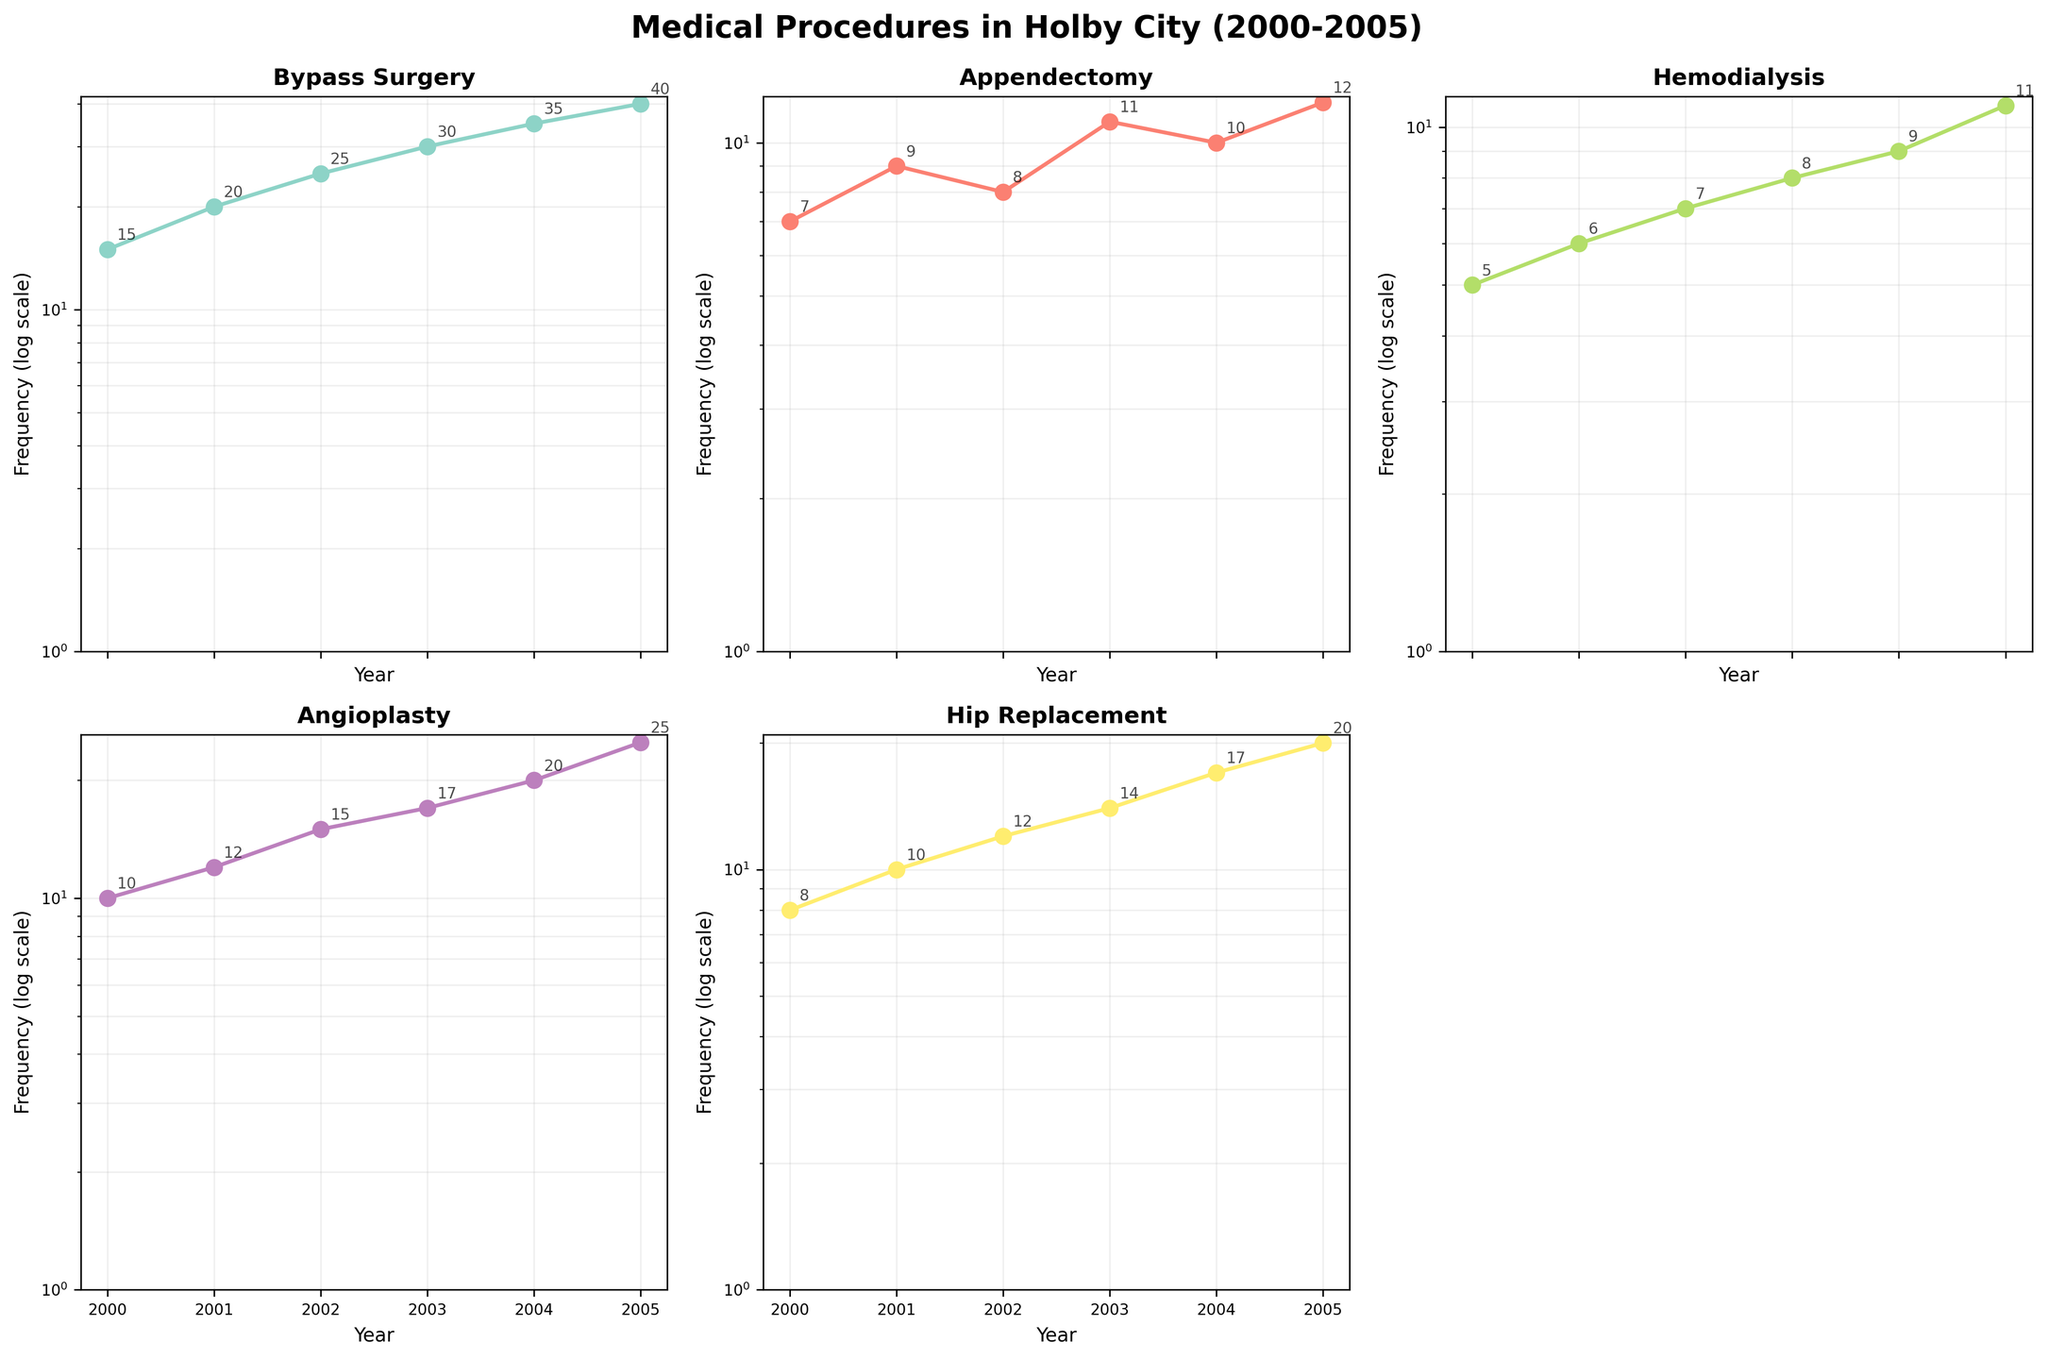When does the subplot indicate the highest frequency for Bypass Surgery? Look at the subplot for Bypass Surgery. The highest frequency value on the y-axis with the log scale corresponds to the year on the x-axis. The highest frequency for Bypass Surgery occurs in 2005.
Answer: 2005 What is the minimum frequency observed for Hemodialysis? Refer to the subplot for Hemodialysis and look for the smallest value on the y-axis which shows frequency in log scale. The minimum frequency for Hemodialysis is 5 in the year 2000.
Answer: 5 Which medical procedure maintains a steady increase in frequency over time? Identify the subplot where the frequency values consistently rise over the years. The subplot for Bypass Surgery shows a consistent increase in frequency each year from 2000 to 2005.
Answer: Bypass Surgery Between Angioplasty and Hip Replacement, which procedure was performed more frequently in 2004? Compare the frequencies of Angioplasty and Hip Replacement for the year 2004 by looking at their respective subplots. Angioplasty has a frequency of 20 in 2004, while Hip Replacement has a frequency of 17. Therefore, Angioplasty was performed more frequently in 2004.
Answer: Angioplasty What is the mean frequency of Appendectomy between 2000 and 2005? Calculate the mean by summing up the frequencies for Appendectomy over the years 2000 to 2005 and dividing by the number of years. The frequencies are 7, 9, 8, 11, 10, 12. Sum = 57, and mean = 57 / 6 = 9.5
Answer: 9.5 Which year shows the smallest frequency for Angioplasty? Refer to the subplot for Angioplasty and find the lowest frequency value on the y-axis and note the corresponding year on the x-axis. The smallest frequency for Angioplasty is 10, which occurs in the year 2000.
Answer: 2000 By how much did the frequency of Bypass Surgery increase from 2000 to 2005? Calculate the difference in the frequency of Bypass Surgery between 2005 and 2000. For the year 2000, the frequency is 15, and for 2005, it is 40. The increase is 40 - 15 = 25.
Answer: 25 Which medical procedure has the most fluctuation in frequency over the years? Examine all subplots to identify which medical procedure shows the most variation in frequency values. Appendectomy shows fluctuating frequencies over the years (7, 9, 8, 11, 10, 12), indicating the most variation.
Answer: Appendectomy 